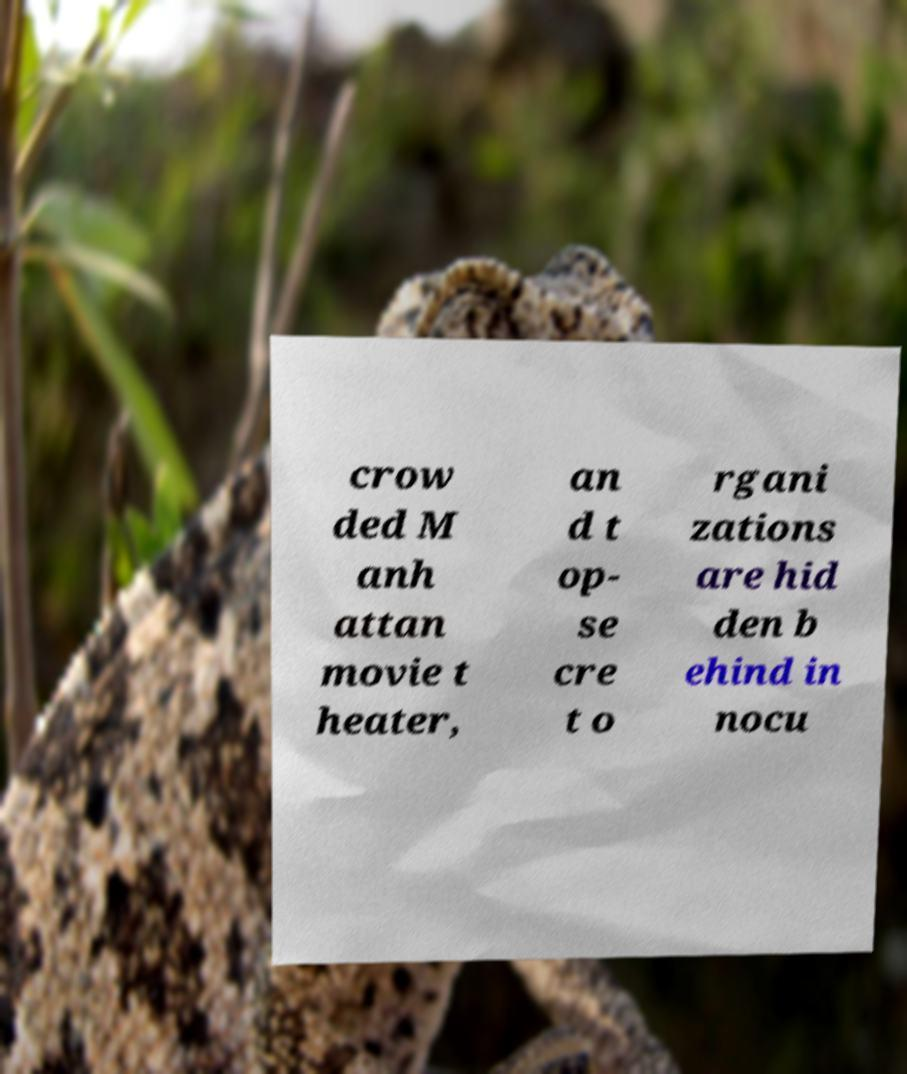Can you accurately transcribe the text from the provided image for me? crow ded M anh attan movie t heater, an d t op- se cre t o rgani zations are hid den b ehind in nocu 